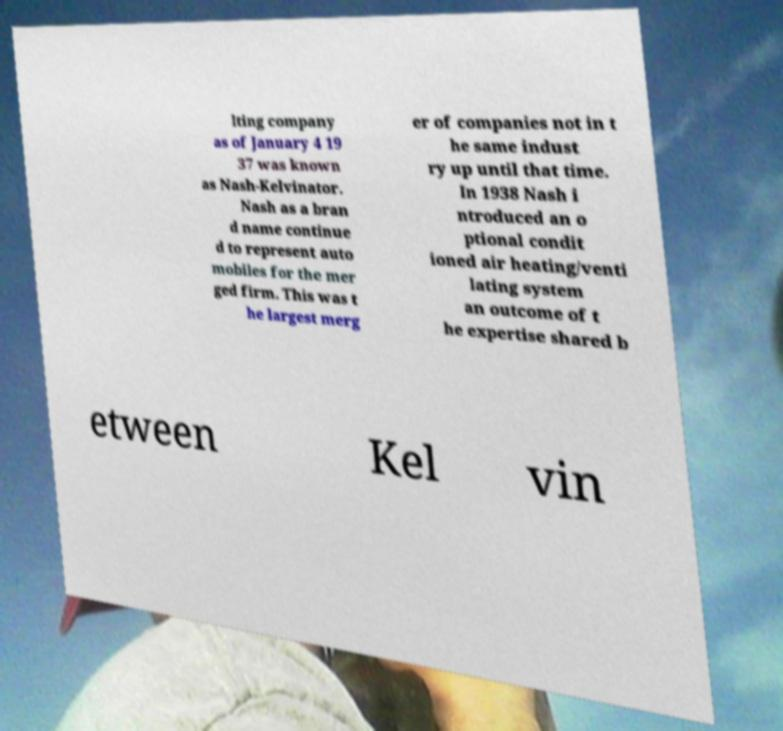Can you read and provide the text displayed in the image?This photo seems to have some interesting text. Can you extract and type it out for me? lting company as of January 4 19 37 was known as Nash-Kelvinator. Nash as a bran d name continue d to represent auto mobiles for the mer ged firm. This was t he largest merg er of companies not in t he same indust ry up until that time. In 1938 Nash i ntroduced an o ptional condit ioned air heating/venti lating system an outcome of t he expertise shared b etween Kel vin 